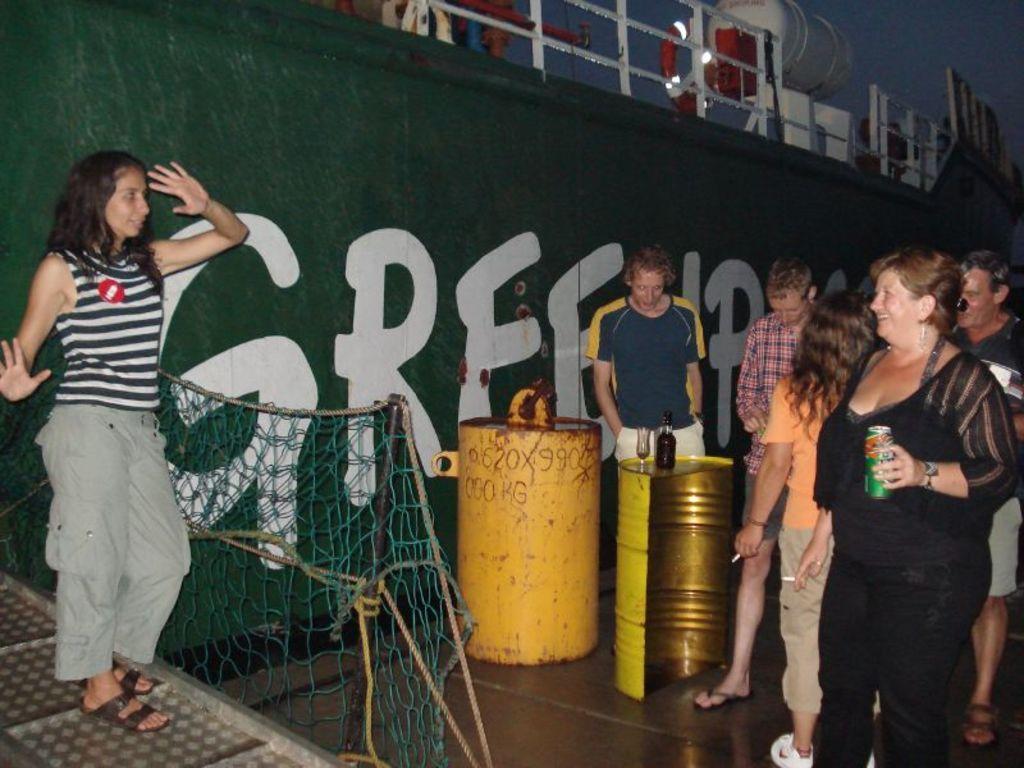In one or two sentences, can you explain what this image depicts? In this image I can see few people are standing and one person is holding something. Back I can see few drums and I can see bottle and few glasses on the drum. Back I can see the green wall, fencing and few objects. 